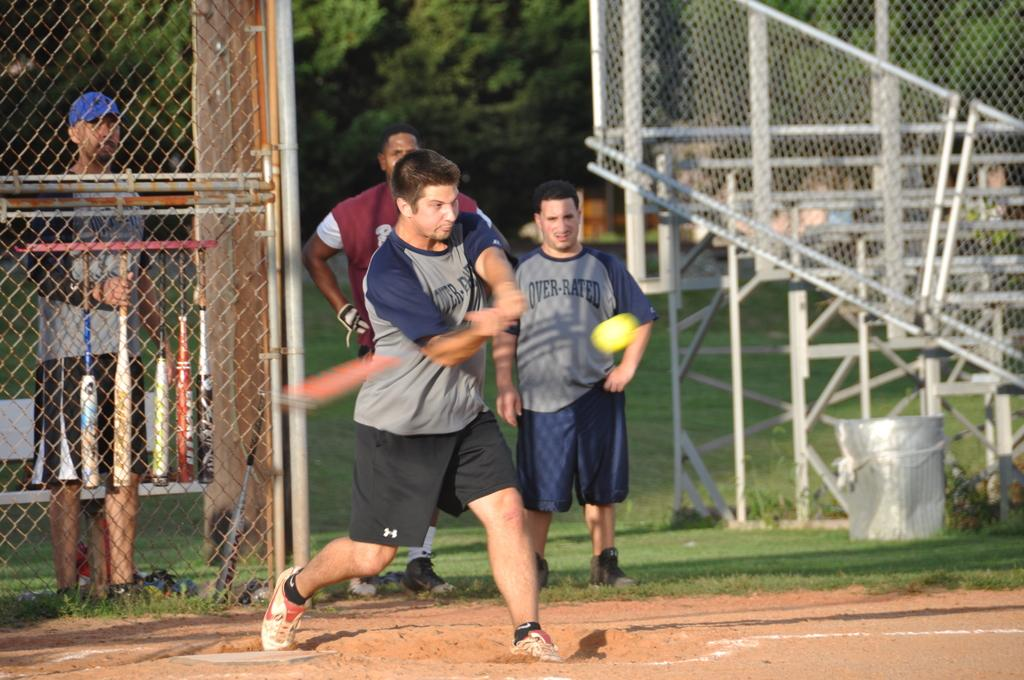What is the man in the image doing? The man is standing and trying to hit a ball in the image. What object is the man holding? The man is holding a bat in the image. Are there any other people in the image? Yes, there are people standing in the image. What can be seen in the background of the image? Trees are visible in the background of the image. What type of mint is growing on the man's finger in the image? There is no mint or any plant growing on the man's finger in the image. 